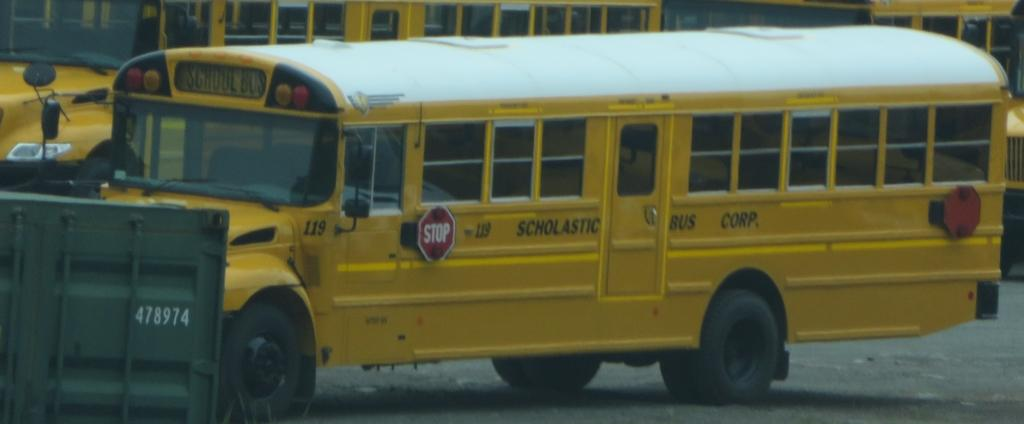<image>
Relay a brief, clear account of the picture shown. A school bus is owed by the scholastic bus corp. 